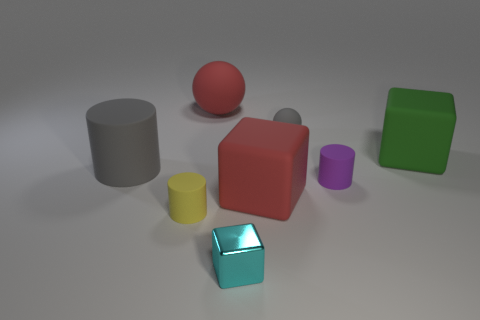Add 2 small cyan matte objects. How many objects exist? 10 Subtract all balls. How many objects are left? 6 Subtract all large red metallic cylinders. Subtract all large green things. How many objects are left? 7 Add 3 red objects. How many red objects are left? 5 Add 2 blue cylinders. How many blue cylinders exist? 2 Subtract 0 cyan spheres. How many objects are left? 8 